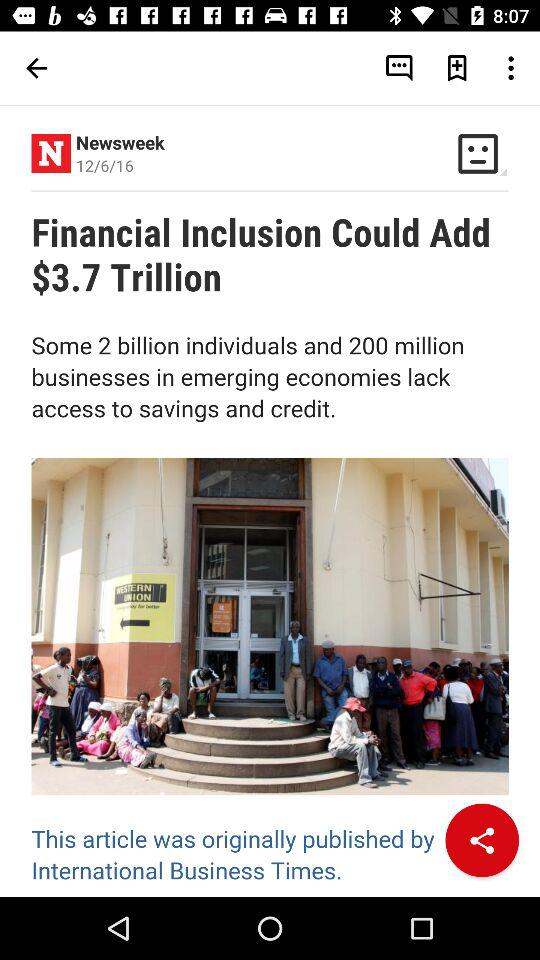How many more people lack access to savings and credit than businesses?
Answer the question using a single word or phrase. 1.8 billion 